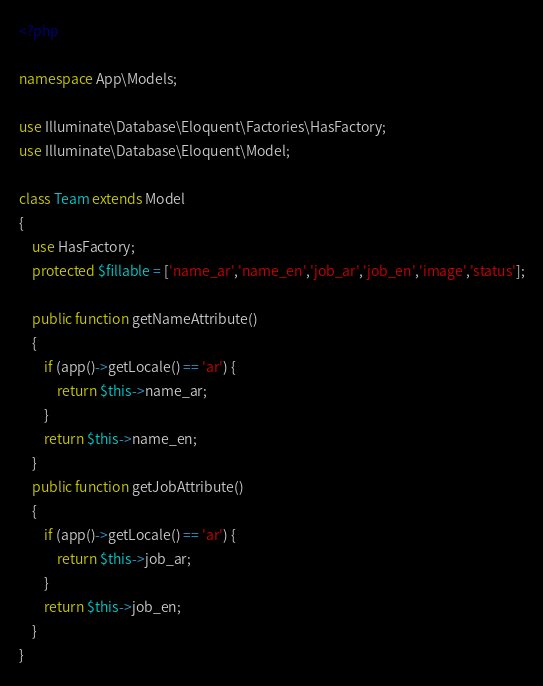Convert code to text. <code><loc_0><loc_0><loc_500><loc_500><_PHP_><?php

namespace App\Models;

use Illuminate\Database\Eloquent\Factories\HasFactory;
use Illuminate\Database\Eloquent\Model;

class Team extends Model
{
    use HasFactory;
    protected $fillable = ['name_ar','name_en','job_ar','job_en','image','status'];
    
    public function getNameAttribute()
    {
        if (app()->getLocale() == 'ar') {
            return $this->name_ar;
        }
        return $this->name_en;
    }
    public function getJobAttribute()
    {
        if (app()->getLocale() == 'ar') {
            return $this->job_ar;
        }
        return $this->job_en;
    }
}
</code> 